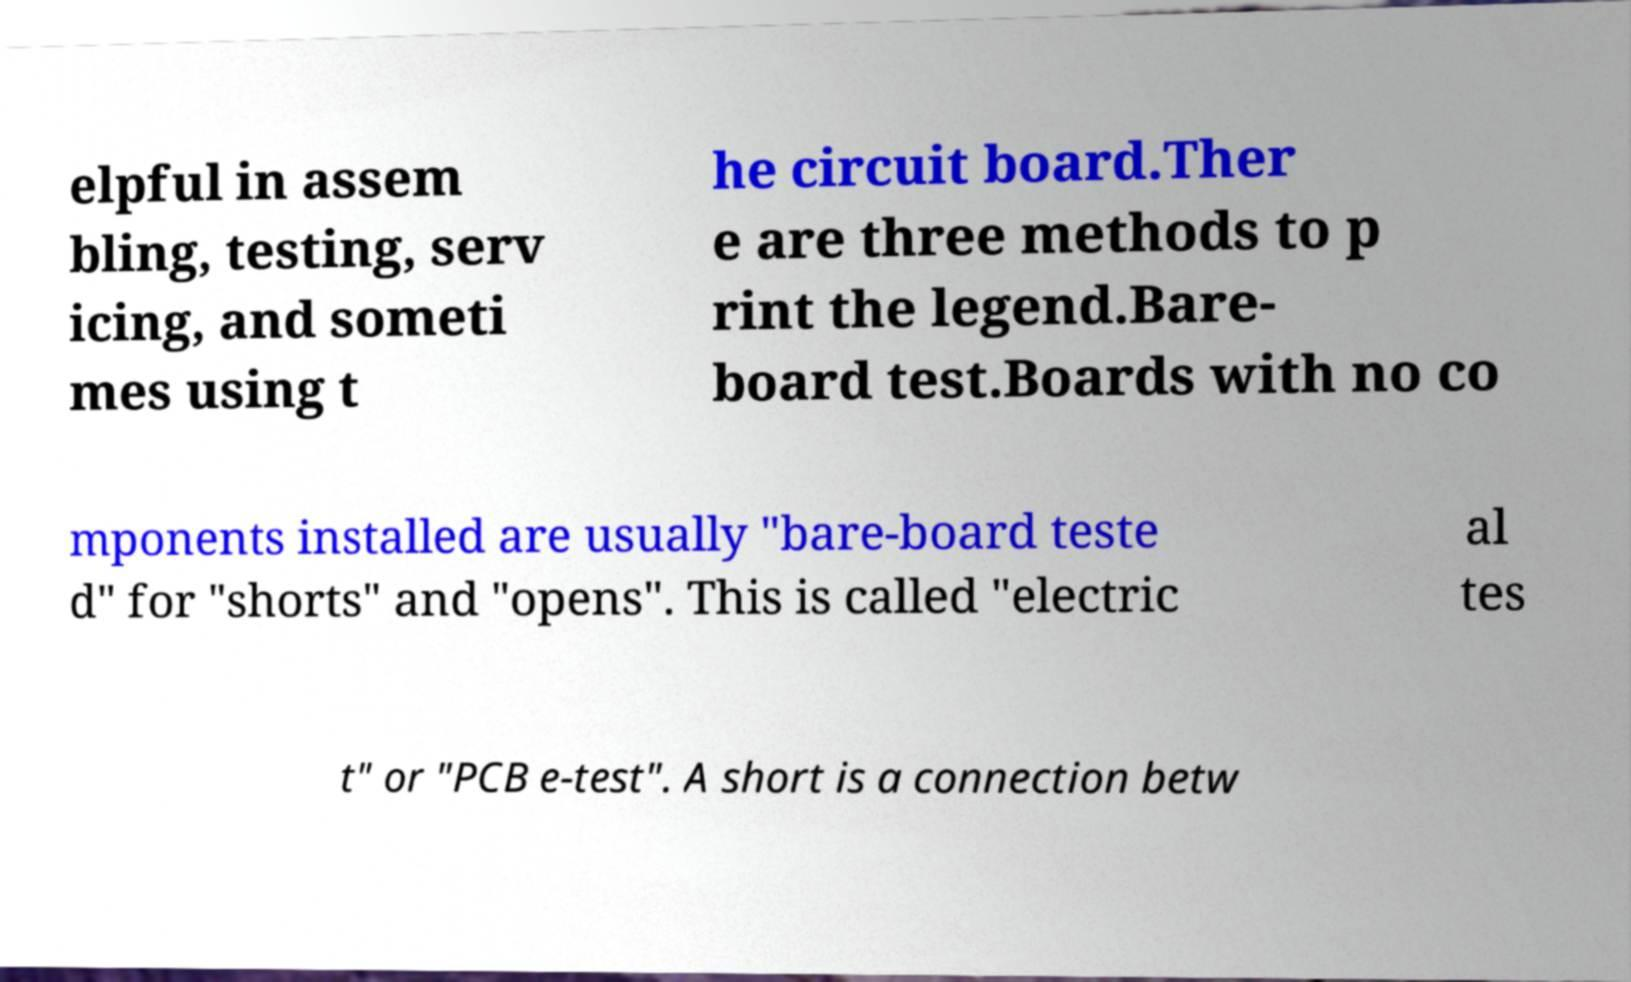For documentation purposes, I need the text within this image transcribed. Could you provide that? elpful in assem bling, testing, serv icing, and someti mes using t he circuit board.Ther e are three methods to p rint the legend.Bare- board test.Boards with no co mponents installed are usually "bare-board teste d" for "shorts" and "opens". This is called "electric al tes t" or "PCB e-test". A short is a connection betw 